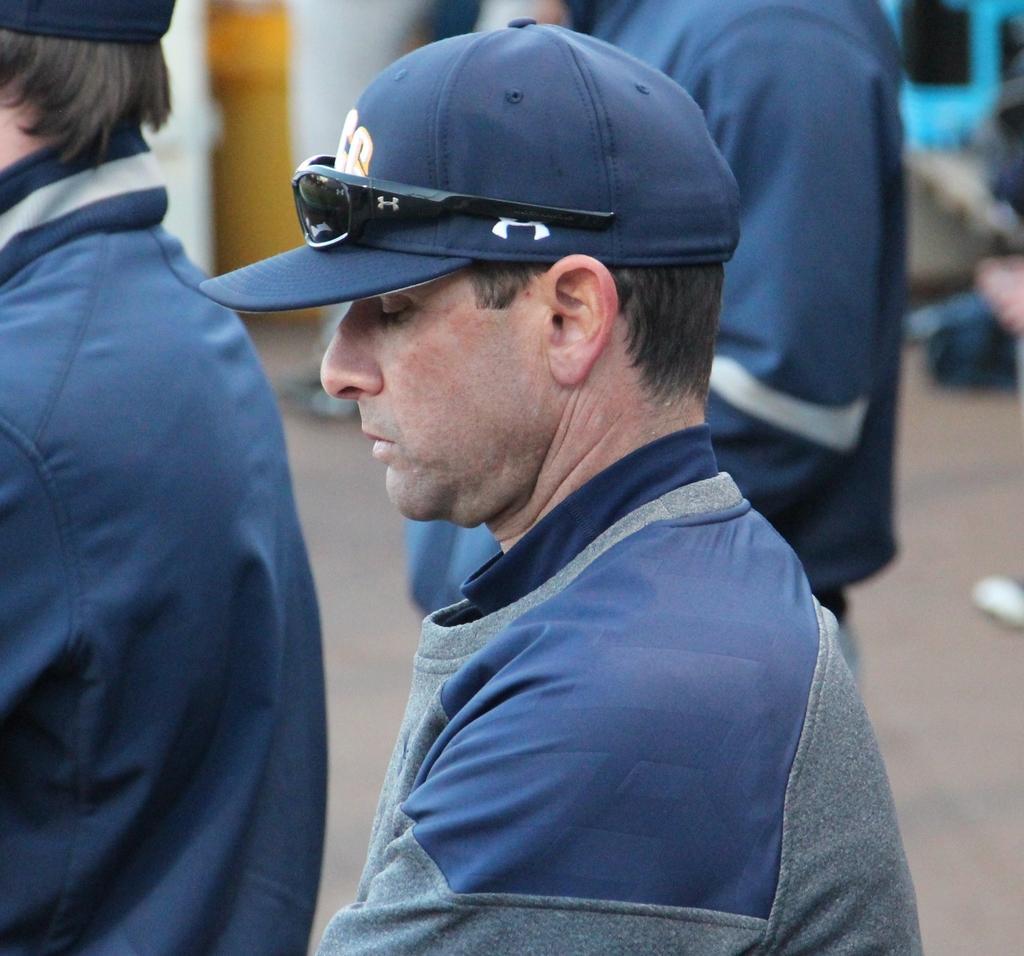Could you give a brief overview of what you see in this image? In the image we can see there are three people standing. A man in between he is wearing a jacket and cap. The black shades are kept on the cap. 